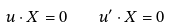<formula> <loc_0><loc_0><loc_500><loc_500>u \cdot X = 0 \quad u ^ { \prime } \cdot X = 0</formula> 